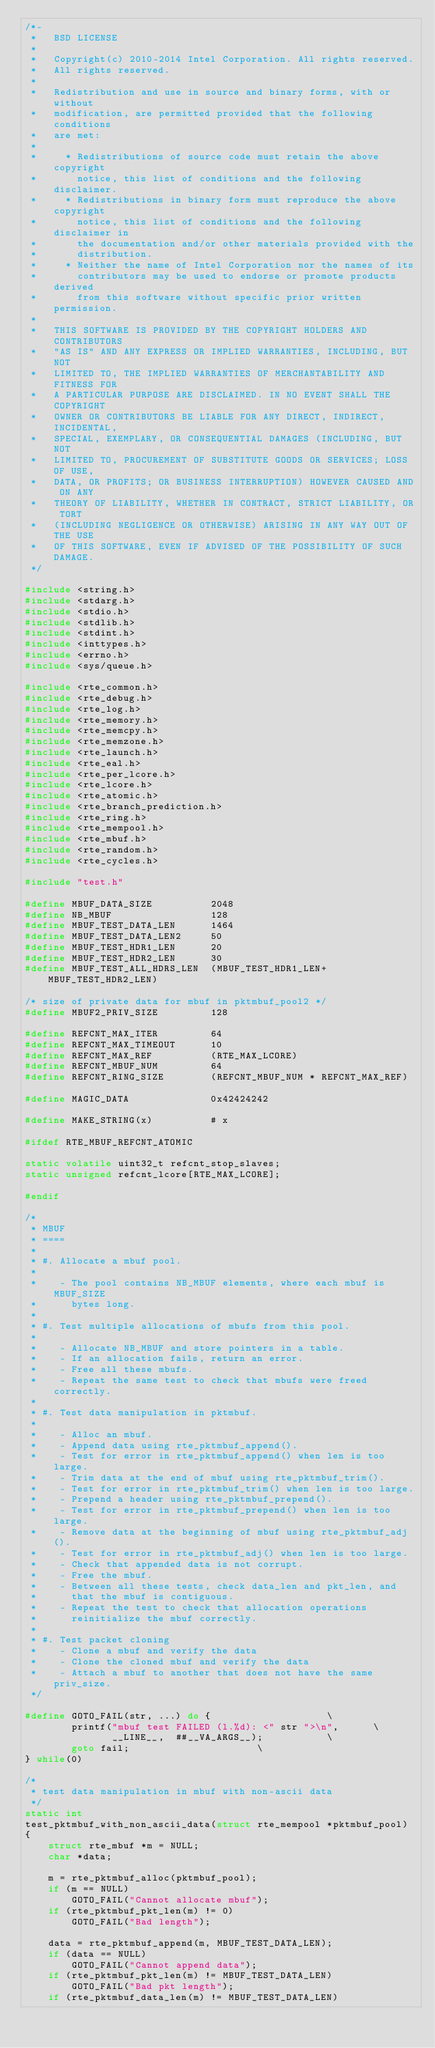Convert code to text. <code><loc_0><loc_0><loc_500><loc_500><_C_>/*-
 *   BSD LICENSE
 *
 *   Copyright(c) 2010-2014 Intel Corporation. All rights reserved.
 *   All rights reserved.
 *
 *   Redistribution and use in source and binary forms, with or without
 *   modification, are permitted provided that the following conditions
 *   are met:
 *
 *     * Redistributions of source code must retain the above copyright
 *       notice, this list of conditions and the following disclaimer.
 *     * Redistributions in binary form must reproduce the above copyright
 *       notice, this list of conditions and the following disclaimer in
 *       the documentation and/or other materials provided with the
 *       distribution.
 *     * Neither the name of Intel Corporation nor the names of its
 *       contributors may be used to endorse or promote products derived
 *       from this software without specific prior written permission.
 *
 *   THIS SOFTWARE IS PROVIDED BY THE COPYRIGHT HOLDERS AND CONTRIBUTORS
 *   "AS IS" AND ANY EXPRESS OR IMPLIED WARRANTIES, INCLUDING, BUT NOT
 *   LIMITED TO, THE IMPLIED WARRANTIES OF MERCHANTABILITY AND FITNESS FOR
 *   A PARTICULAR PURPOSE ARE DISCLAIMED. IN NO EVENT SHALL THE COPYRIGHT
 *   OWNER OR CONTRIBUTORS BE LIABLE FOR ANY DIRECT, INDIRECT, INCIDENTAL,
 *   SPECIAL, EXEMPLARY, OR CONSEQUENTIAL DAMAGES (INCLUDING, BUT NOT
 *   LIMITED TO, PROCUREMENT OF SUBSTITUTE GOODS OR SERVICES; LOSS OF USE,
 *   DATA, OR PROFITS; OR BUSINESS INTERRUPTION) HOWEVER CAUSED AND ON ANY
 *   THEORY OF LIABILITY, WHETHER IN CONTRACT, STRICT LIABILITY, OR TORT
 *   (INCLUDING NEGLIGENCE OR OTHERWISE) ARISING IN ANY WAY OUT OF THE USE
 *   OF THIS SOFTWARE, EVEN IF ADVISED OF THE POSSIBILITY OF SUCH DAMAGE.
 */

#include <string.h>
#include <stdarg.h>
#include <stdio.h>
#include <stdlib.h>
#include <stdint.h>
#include <inttypes.h>
#include <errno.h>
#include <sys/queue.h>

#include <rte_common.h>
#include <rte_debug.h>
#include <rte_log.h>
#include <rte_memory.h>
#include <rte_memcpy.h>
#include <rte_memzone.h>
#include <rte_launch.h>
#include <rte_eal.h>
#include <rte_per_lcore.h>
#include <rte_lcore.h>
#include <rte_atomic.h>
#include <rte_branch_prediction.h>
#include <rte_ring.h>
#include <rte_mempool.h>
#include <rte_mbuf.h>
#include <rte_random.h>
#include <rte_cycles.h>

#include "test.h"

#define MBUF_DATA_SIZE          2048
#define NB_MBUF                 128
#define MBUF_TEST_DATA_LEN      1464
#define MBUF_TEST_DATA_LEN2     50
#define MBUF_TEST_HDR1_LEN      20
#define MBUF_TEST_HDR2_LEN      30
#define MBUF_TEST_ALL_HDRS_LEN  (MBUF_TEST_HDR1_LEN+MBUF_TEST_HDR2_LEN)

/* size of private data for mbuf in pktmbuf_pool2 */
#define MBUF2_PRIV_SIZE         128

#define REFCNT_MAX_ITER         64
#define REFCNT_MAX_TIMEOUT      10
#define REFCNT_MAX_REF          (RTE_MAX_LCORE)
#define REFCNT_MBUF_NUM         64
#define REFCNT_RING_SIZE        (REFCNT_MBUF_NUM * REFCNT_MAX_REF)

#define MAGIC_DATA              0x42424242

#define MAKE_STRING(x)          # x

#ifdef RTE_MBUF_REFCNT_ATOMIC

static volatile uint32_t refcnt_stop_slaves;
static unsigned refcnt_lcore[RTE_MAX_LCORE];

#endif

/*
 * MBUF
 * ====
 *
 * #. Allocate a mbuf pool.
 *
 *    - The pool contains NB_MBUF elements, where each mbuf is MBUF_SIZE
 *      bytes long.
 *
 * #. Test multiple allocations of mbufs from this pool.
 *
 *    - Allocate NB_MBUF and store pointers in a table.
 *    - If an allocation fails, return an error.
 *    - Free all these mbufs.
 *    - Repeat the same test to check that mbufs were freed correctly.
 *
 * #. Test data manipulation in pktmbuf.
 *
 *    - Alloc an mbuf.
 *    - Append data using rte_pktmbuf_append().
 *    - Test for error in rte_pktmbuf_append() when len is too large.
 *    - Trim data at the end of mbuf using rte_pktmbuf_trim().
 *    - Test for error in rte_pktmbuf_trim() when len is too large.
 *    - Prepend a header using rte_pktmbuf_prepend().
 *    - Test for error in rte_pktmbuf_prepend() when len is too large.
 *    - Remove data at the beginning of mbuf using rte_pktmbuf_adj().
 *    - Test for error in rte_pktmbuf_adj() when len is too large.
 *    - Check that appended data is not corrupt.
 *    - Free the mbuf.
 *    - Between all these tests, check data_len and pkt_len, and
 *      that the mbuf is contiguous.
 *    - Repeat the test to check that allocation operations
 *      reinitialize the mbuf correctly.
 *
 * #. Test packet cloning
 *    - Clone a mbuf and verify the data
 *    - Clone the cloned mbuf and verify the data
 *    - Attach a mbuf to another that does not have the same priv_size.
 */

#define GOTO_FAIL(str, ...) do {					\
		printf("mbuf test FAILED (l.%d): <" str ">\n",		\
		       __LINE__,  ##__VA_ARGS__);			\
		goto fail;						\
} while(0)

/*
 * test data manipulation in mbuf with non-ascii data
 */
static int
test_pktmbuf_with_non_ascii_data(struct rte_mempool *pktmbuf_pool)
{
	struct rte_mbuf *m = NULL;
	char *data;

	m = rte_pktmbuf_alloc(pktmbuf_pool);
	if (m == NULL)
		GOTO_FAIL("Cannot allocate mbuf");
	if (rte_pktmbuf_pkt_len(m) != 0)
		GOTO_FAIL("Bad length");

	data = rte_pktmbuf_append(m, MBUF_TEST_DATA_LEN);
	if (data == NULL)
		GOTO_FAIL("Cannot append data");
	if (rte_pktmbuf_pkt_len(m) != MBUF_TEST_DATA_LEN)
		GOTO_FAIL("Bad pkt length");
	if (rte_pktmbuf_data_len(m) != MBUF_TEST_DATA_LEN)</code> 